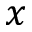<formula> <loc_0><loc_0><loc_500><loc_500>x</formula> 